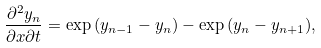<formula> <loc_0><loc_0><loc_500><loc_500>\frac { \partial ^ { 2 } y _ { n } } { \partial x \partial t } = \exp { ( y _ { n - 1 } - y _ { n } ) } - \exp { ( y _ { n } - y _ { n + 1 } ) } ,</formula> 